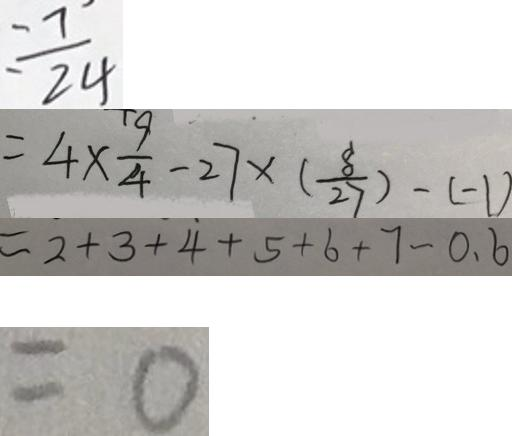<formula> <loc_0><loc_0><loc_500><loc_500>= \frac { 7 } { 2 4 } 
 = 4 \times \frac { 9 } { 4 } - 2 7 \times ( \frac { 8 } { 2 7 } ) - ( - 1 ) 
 = 2 + 3 + 4 + 5 + 6 + 7 - 0 . 6 
 = 0</formula> 